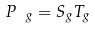Convert formula to latex. <formula><loc_0><loc_0><loc_500><loc_500>P _ { \ g } = S _ { g } T _ { g }</formula> 